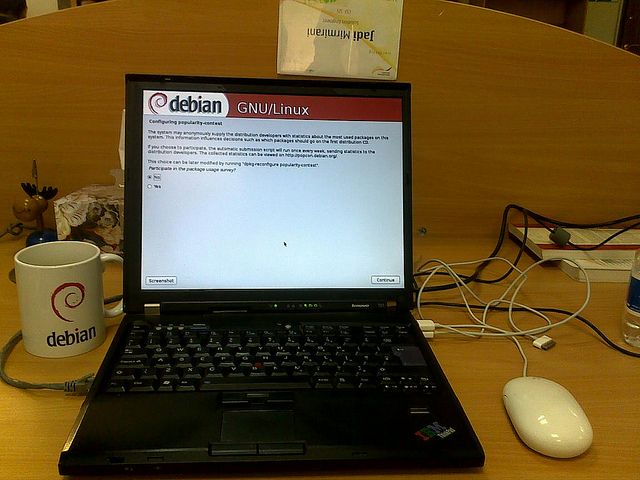<image>What brand is the computer? I am not sure what brand the computer is. It can be IBM, IDM, or Dell. What liquid is in the bottle? It is uncertain what liquid is in the bottle. It could be coffee or water, or there may be no bottle at all. What kind of laptop is this? I am not sure. The laptop could be IBM, Dell, Asus or Samsung. What brand is the computer? I am not sure what brand is the computer. It can be 'idm', 'ibm' or 'dell'. What liquid is in the bottle? There is no bottle in the image. What kind of laptop is this? I am not sure what kind of laptop this is. It can be seen as 'ibm', 'dell', 'asus' or 'samsung'. 